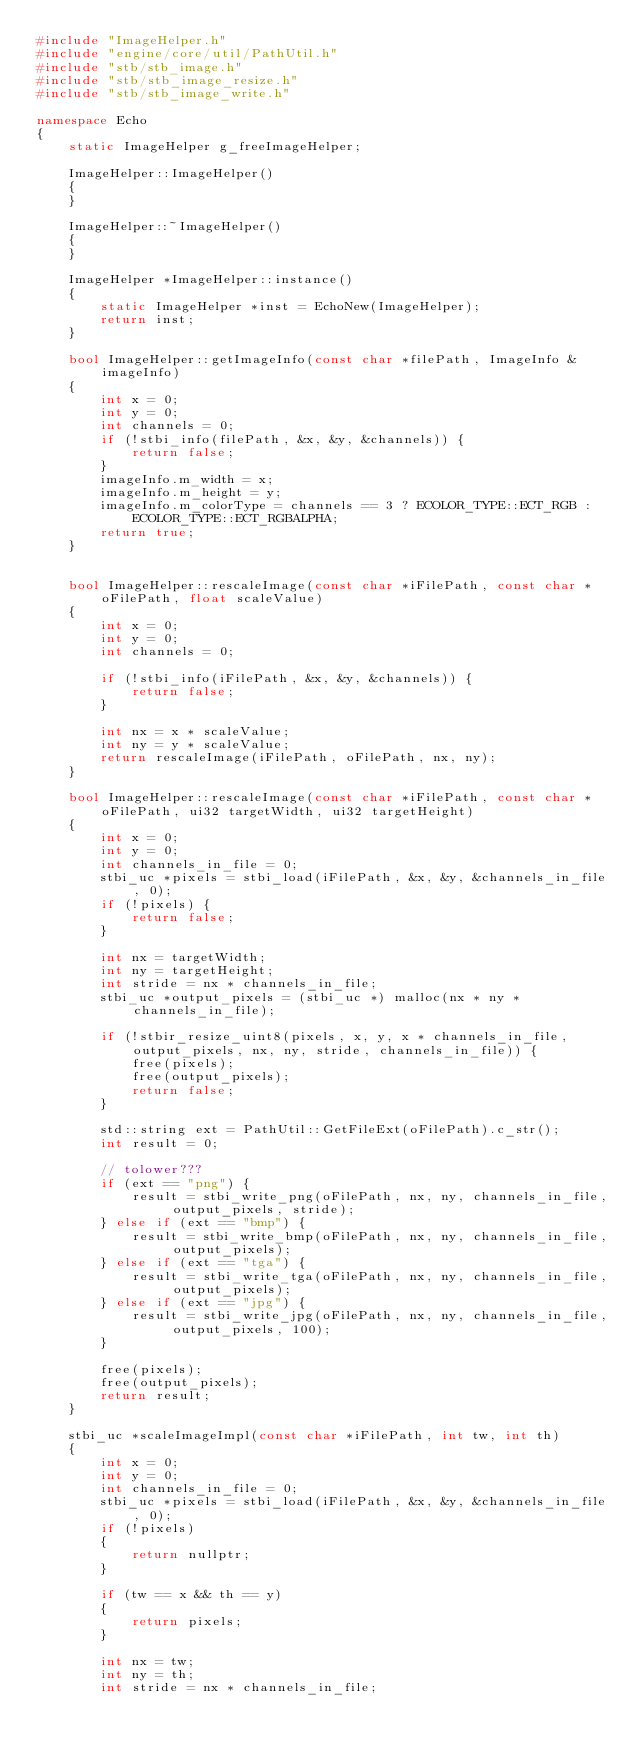Convert code to text. <code><loc_0><loc_0><loc_500><loc_500><_C++_>#include "ImageHelper.h"
#include "engine/core/util/PathUtil.h"
#include "stb/stb_image.h"
#include "stb/stb_image_resize.h"
#include "stb/stb_image_write.h"

namespace Echo
{
    static ImageHelper g_freeImageHelper;

    ImageHelper::ImageHelper() 
    {
    }

    ImageHelper::~ImageHelper() 
    {
    }

    ImageHelper *ImageHelper::instance()
    {
        static ImageHelper *inst = EchoNew(ImageHelper);
        return inst;
    }

    bool ImageHelper::getImageInfo(const char *filePath, ImageInfo &imageInfo)
    {
        int x = 0;
        int y = 0;
        int channels = 0;
        if (!stbi_info(filePath, &x, &y, &channels)) {
            return false;
        }
        imageInfo.m_width = x;
        imageInfo.m_height = y;
        imageInfo.m_colorType = channels == 3 ? ECOLOR_TYPE::ECT_RGB : ECOLOR_TYPE::ECT_RGBALPHA;
        return true;
    }


    bool ImageHelper::rescaleImage(const char *iFilePath, const char *oFilePath, float scaleValue) 
    {
        int x = 0;
        int y = 0;
        int channels = 0;

        if (!stbi_info(iFilePath, &x, &y, &channels)) {
            return false;
        }

        int nx = x * scaleValue;
        int ny = y * scaleValue;
        return rescaleImage(iFilePath, oFilePath, nx, ny);
    }

    bool ImageHelper::rescaleImage(const char *iFilePath, const char *oFilePath, ui32 targetWidth, ui32 targetHeight)
    {
        int x = 0;
        int y = 0;
        int channels_in_file = 0;
        stbi_uc *pixels = stbi_load(iFilePath, &x, &y, &channels_in_file, 0);
        if (!pixels) {
            return false;
        }

        int nx = targetWidth;
        int ny = targetHeight;
        int stride = nx * channels_in_file;
        stbi_uc *output_pixels = (stbi_uc *) malloc(nx * ny * channels_in_file);

        if (!stbir_resize_uint8(pixels, x, y, x * channels_in_file, output_pixels, nx, ny, stride, channels_in_file)) {
            free(pixels);
            free(output_pixels);
            return false;
        }

        std::string ext = PathUtil::GetFileExt(oFilePath).c_str();
        int result = 0;

        // tolower???
        if (ext == "png") {
            result = stbi_write_png(oFilePath, nx, ny, channels_in_file, output_pixels, stride);
        } else if (ext == "bmp") {
            result = stbi_write_bmp(oFilePath, nx, ny, channels_in_file, output_pixels);
        } else if (ext == "tga") {
            result = stbi_write_tga(oFilePath, nx, ny, channels_in_file, output_pixels);
        } else if (ext == "jpg") {
            result = stbi_write_jpg(oFilePath, nx, ny, channels_in_file, output_pixels, 100);
        }

        free(pixels);
        free(output_pixels);
        return result;
    }

    stbi_uc *scaleImageImpl(const char *iFilePath, int tw, int th) 
    {
        int x = 0;
        int y = 0;
        int channels_in_file = 0;
        stbi_uc *pixels = stbi_load(iFilePath, &x, &y, &channels_in_file, 0);
        if (!pixels) 
        {
            return nullptr;
        }

        if (tw == x && th == y) 
        {
            return pixels;
        }

        int nx = tw;
        int ny = th;
        int stride = nx * channels_in_file;</code> 